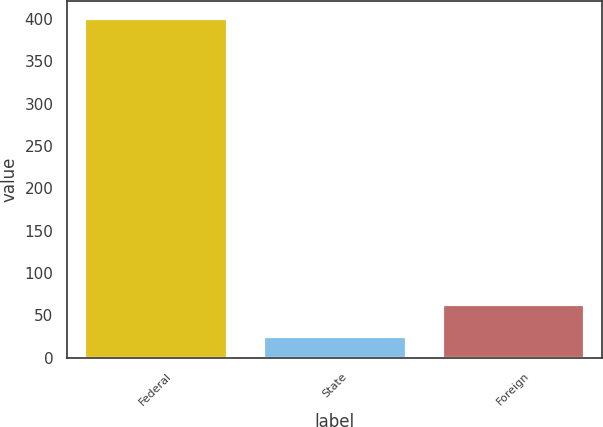Convert chart. <chart><loc_0><loc_0><loc_500><loc_500><bar_chart><fcel>Federal<fcel>State<fcel>Foreign<nl><fcel>401<fcel>26<fcel>63.5<nl></chart> 